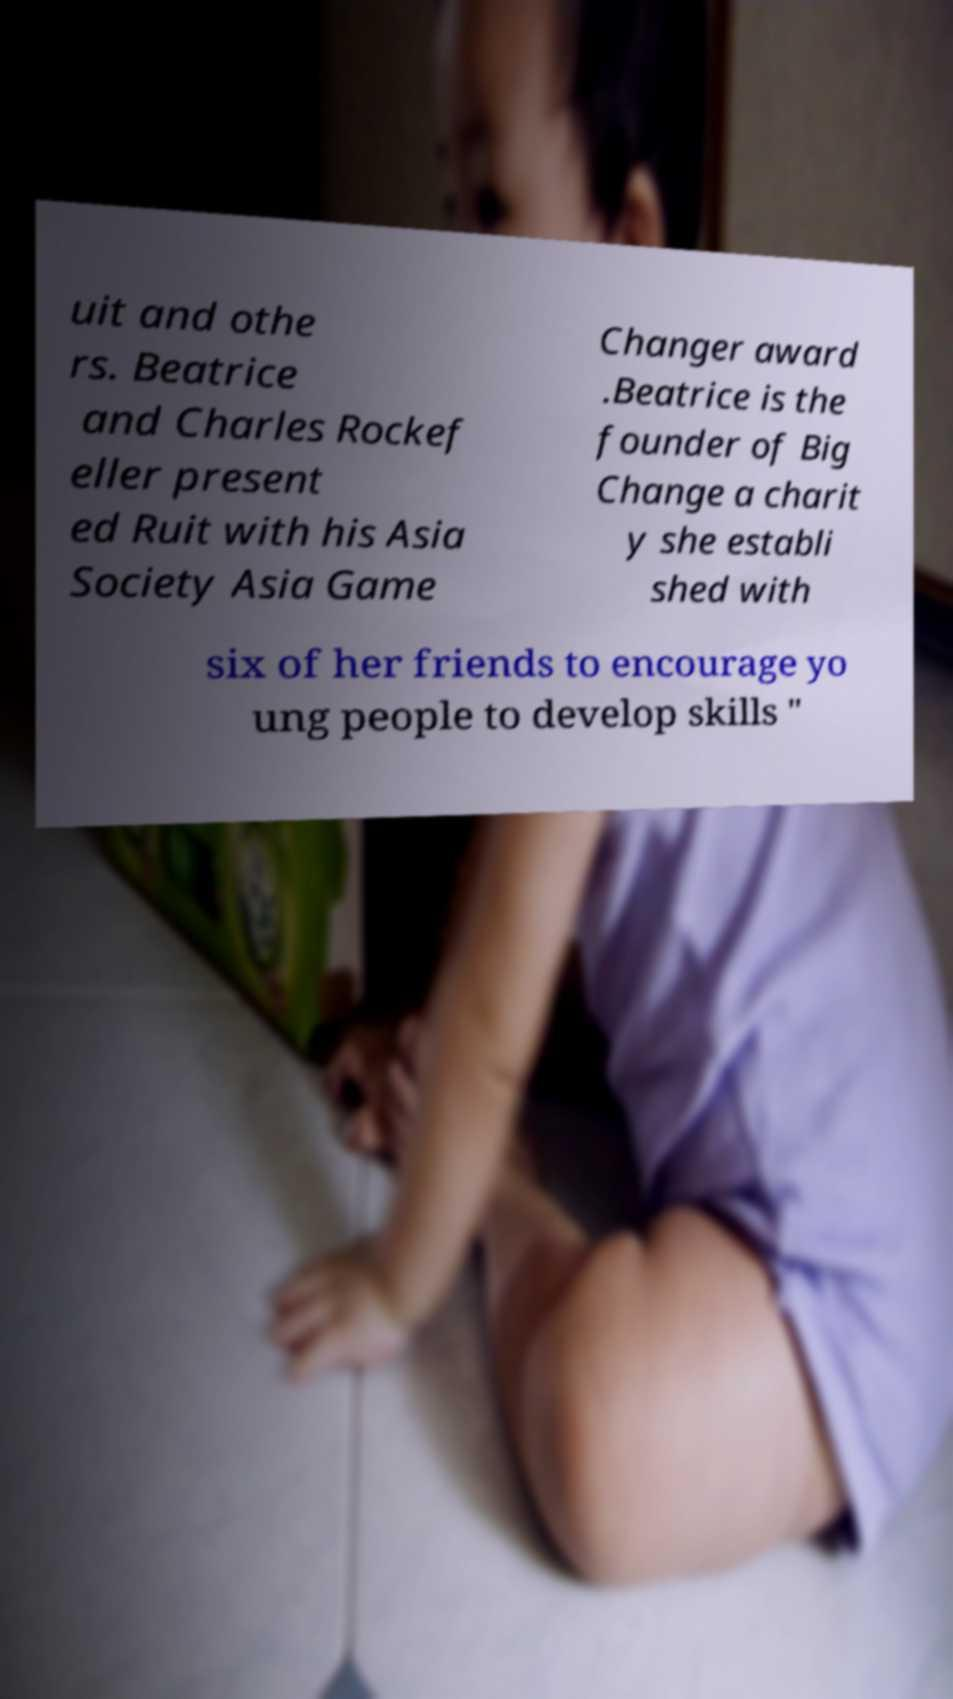Can you read and provide the text displayed in the image?This photo seems to have some interesting text. Can you extract and type it out for me? uit and othe rs. Beatrice and Charles Rockef eller present ed Ruit with his Asia Society Asia Game Changer award .Beatrice is the founder of Big Change a charit y she establi shed with six of her friends to encourage yo ung people to develop skills " 